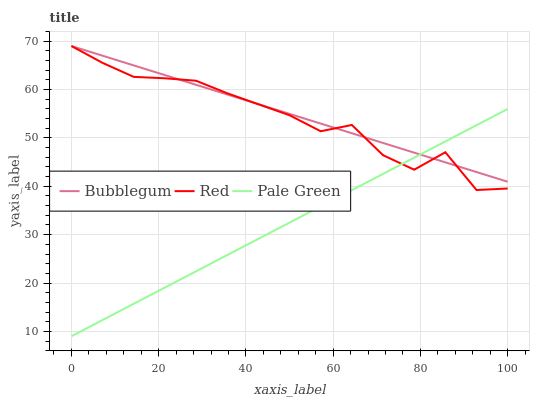Does Pale Green have the minimum area under the curve?
Answer yes or no. Yes. Does Bubblegum have the maximum area under the curve?
Answer yes or no. Yes. Does Red have the minimum area under the curve?
Answer yes or no. No. Does Red have the maximum area under the curve?
Answer yes or no. No. Is Pale Green the smoothest?
Answer yes or no. Yes. Is Red the roughest?
Answer yes or no. Yes. Is Bubblegum the smoothest?
Answer yes or no. No. Is Bubblegum the roughest?
Answer yes or no. No. Does Red have the lowest value?
Answer yes or no. No. 